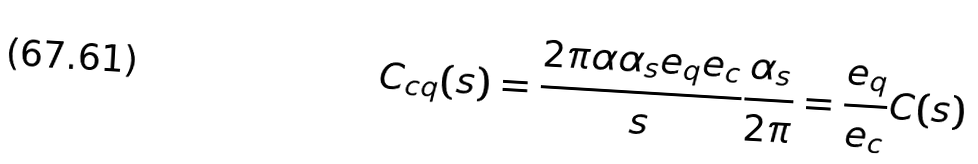<formula> <loc_0><loc_0><loc_500><loc_500>C _ { c q } ( s ) = \frac { 2 \pi \alpha \alpha _ { s } e _ { q } e _ { c } } { s } \frac { \alpha _ { s } } { 2 \pi } = \frac { e _ { q } } { e _ { c } } C ( s )</formula> 